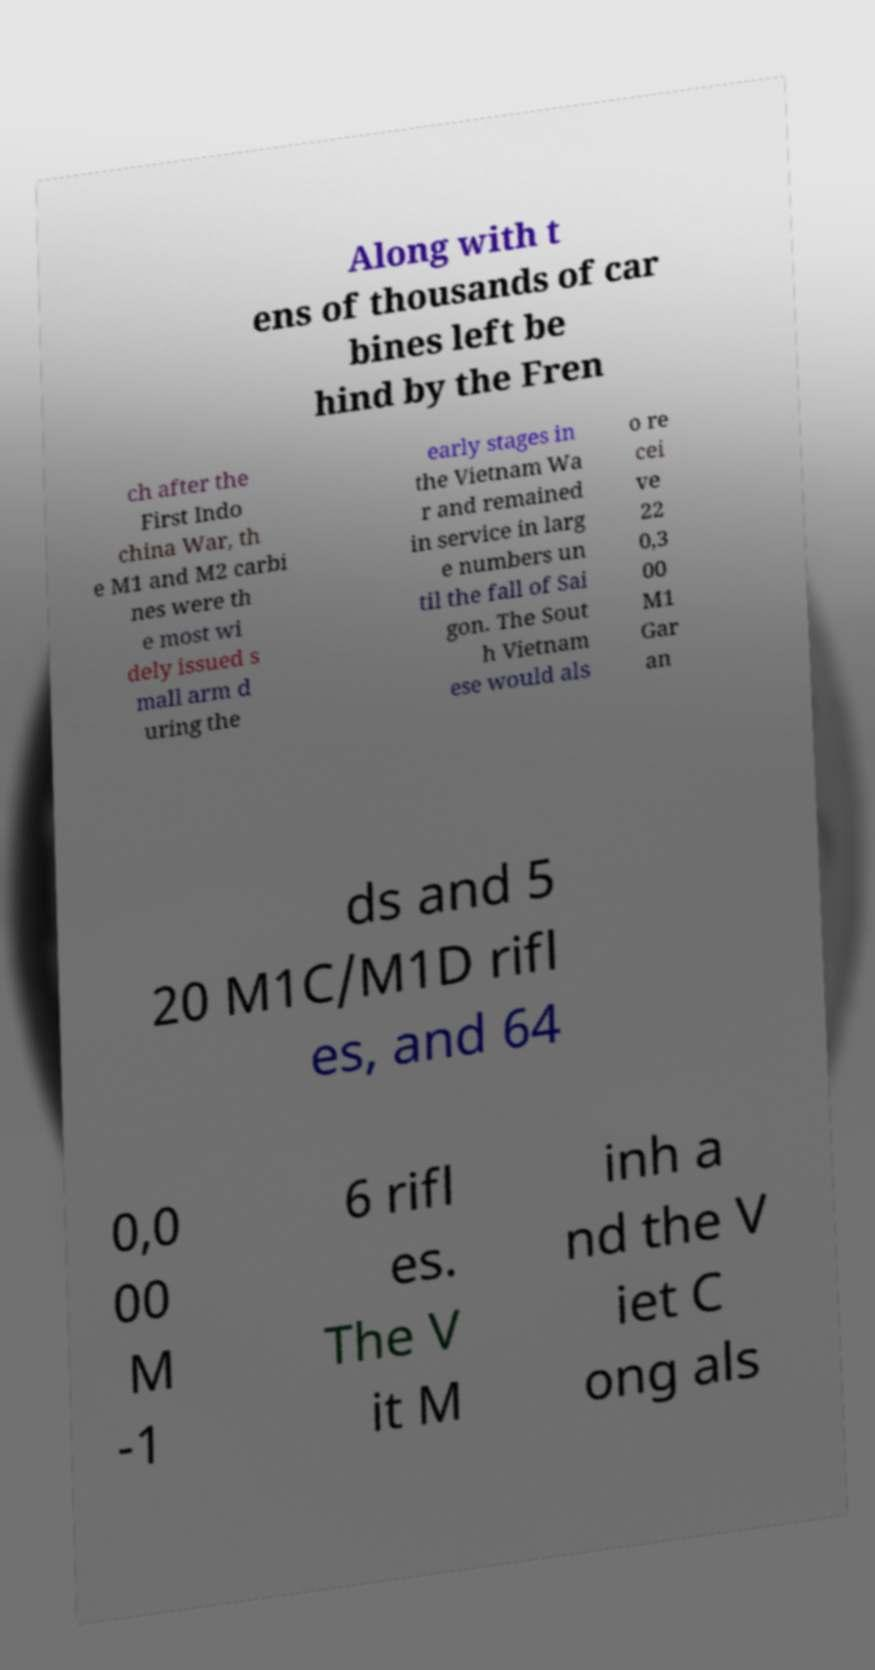For documentation purposes, I need the text within this image transcribed. Could you provide that? Along with t ens of thousands of car bines left be hind by the Fren ch after the First Indo china War, th e M1 and M2 carbi nes were th e most wi dely issued s mall arm d uring the early stages in the Vietnam Wa r and remained in service in larg e numbers un til the fall of Sai gon. The Sout h Vietnam ese would als o re cei ve 22 0,3 00 M1 Gar an ds and 5 20 M1C/M1D rifl es, and 64 0,0 00 M -1 6 rifl es. The V it M inh a nd the V iet C ong als 